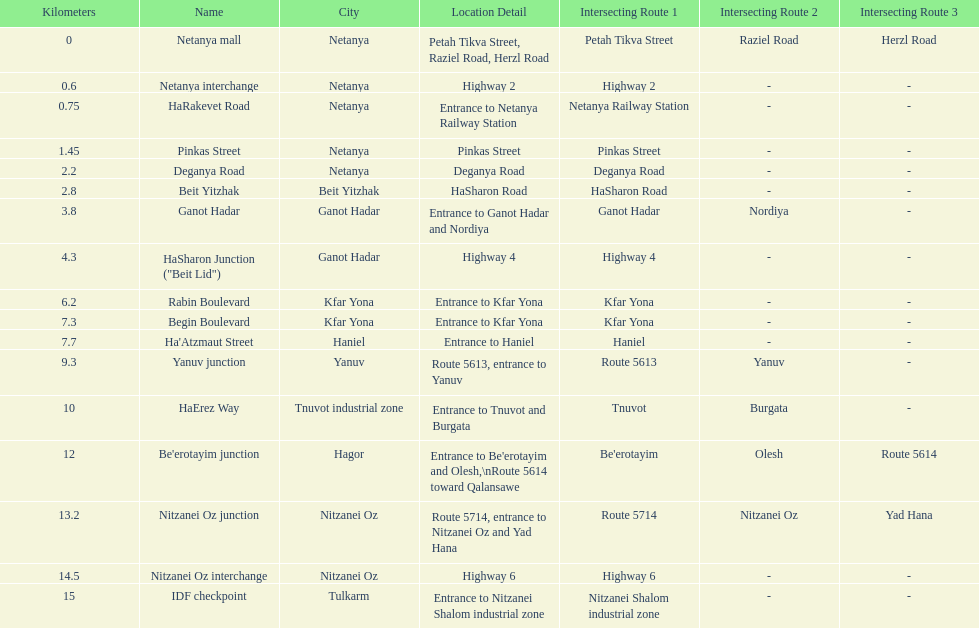Which portion has the same intersecting route as rabin boulevard? Begin Boulevard. 